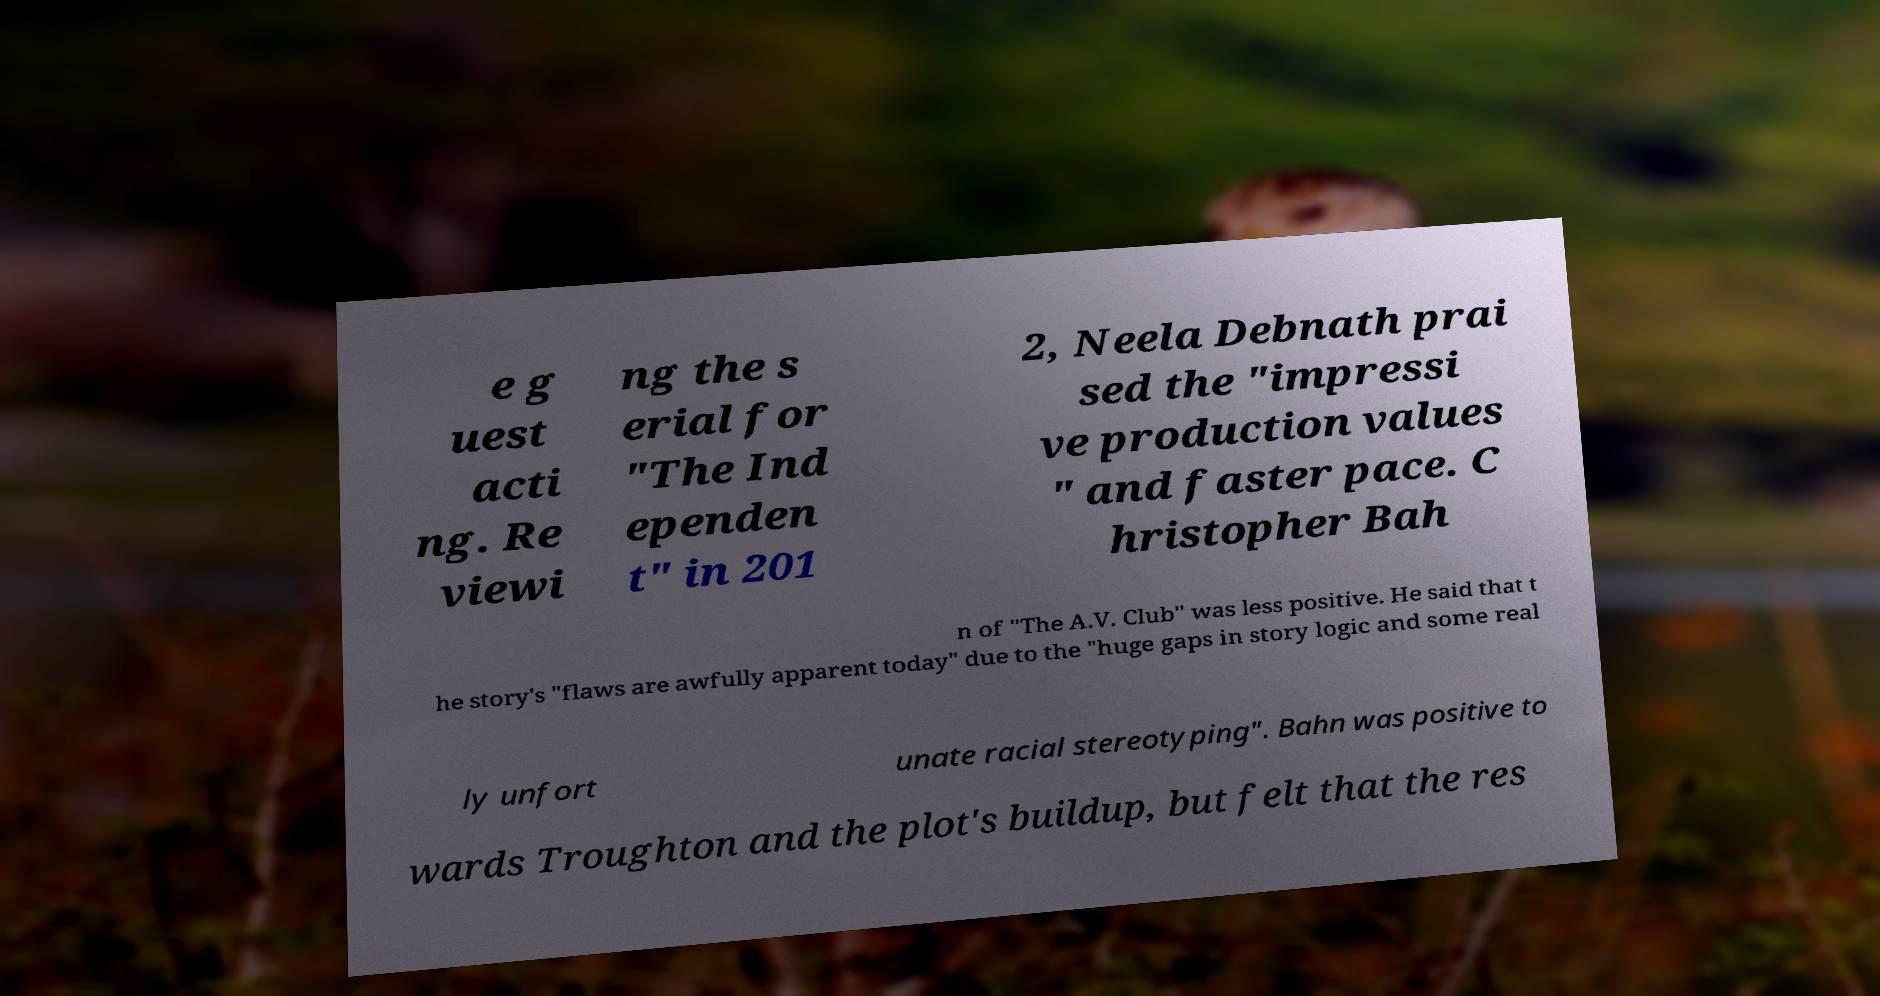Could you assist in decoding the text presented in this image and type it out clearly? e g uest acti ng. Re viewi ng the s erial for "The Ind ependen t" in 201 2, Neela Debnath prai sed the "impressi ve production values " and faster pace. C hristopher Bah n of "The A.V. Club" was less positive. He said that t he story's "flaws are awfully apparent today" due to the "huge gaps in story logic and some real ly unfort unate racial stereotyping". Bahn was positive to wards Troughton and the plot's buildup, but felt that the res 